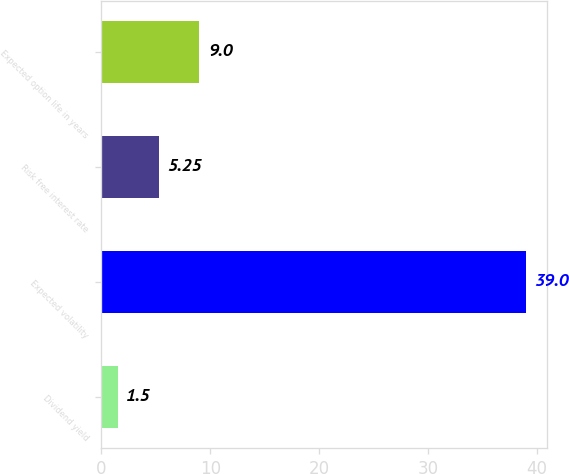Convert chart to OTSL. <chart><loc_0><loc_0><loc_500><loc_500><bar_chart><fcel>Dividend yield<fcel>Expected volatility<fcel>Risk free interest rate<fcel>Expected option life in years<nl><fcel>1.5<fcel>39<fcel>5.25<fcel>9<nl></chart> 